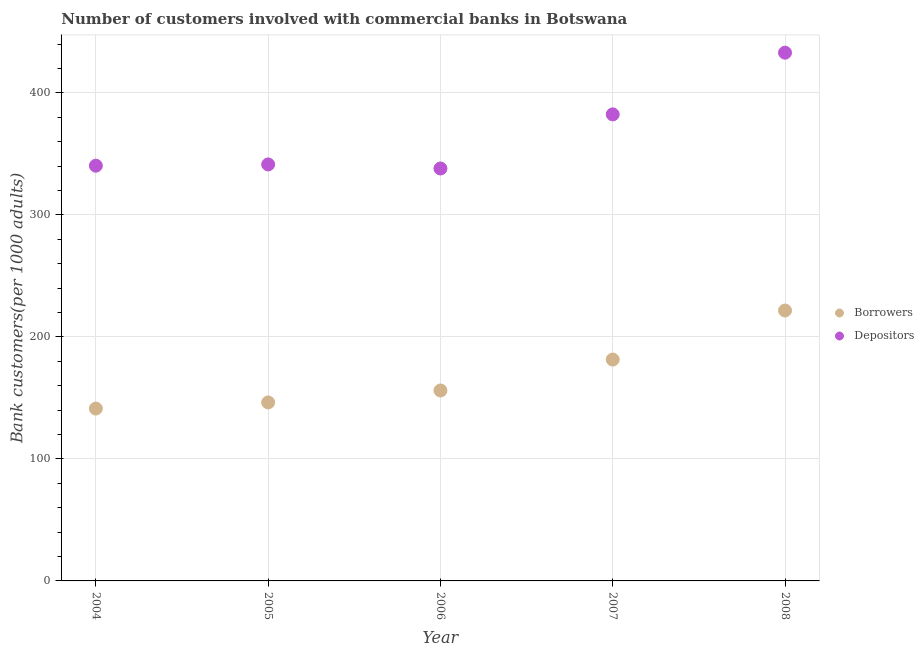How many different coloured dotlines are there?
Your answer should be compact. 2. Is the number of dotlines equal to the number of legend labels?
Offer a terse response. Yes. What is the number of borrowers in 2006?
Provide a short and direct response. 156.11. Across all years, what is the maximum number of depositors?
Your answer should be compact. 433.02. Across all years, what is the minimum number of borrowers?
Offer a terse response. 141.29. In which year was the number of depositors maximum?
Provide a succinct answer. 2008. What is the total number of depositors in the graph?
Your answer should be compact. 1835.3. What is the difference between the number of borrowers in 2004 and that in 2005?
Provide a short and direct response. -5.03. What is the difference between the number of borrowers in 2006 and the number of depositors in 2004?
Your answer should be very brief. -184.26. What is the average number of depositors per year?
Make the answer very short. 367.06. In the year 2006, what is the difference between the number of depositors and number of borrowers?
Your answer should be compact. 181.96. In how many years, is the number of depositors greater than 420?
Provide a short and direct response. 1. What is the ratio of the number of borrowers in 2004 to that in 2008?
Provide a succinct answer. 0.64. Is the number of borrowers in 2005 less than that in 2006?
Your answer should be very brief. Yes. Is the difference between the number of borrowers in 2004 and 2005 greater than the difference between the number of depositors in 2004 and 2005?
Offer a very short reply. No. What is the difference between the highest and the second highest number of borrowers?
Your response must be concise. 40.2. What is the difference between the highest and the lowest number of depositors?
Keep it short and to the point. 94.94. Is the sum of the number of borrowers in 2005 and 2007 greater than the maximum number of depositors across all years?
Ensure brevity in your answer.  No. Is the number of depositors strictly greater than the number of borrowers over the years?
Provide a short and direct response. Yes. How many dotlines are there?
Your answer should be very brief. 2. How many years are there in the graph?
Keep it short and to the point. 5. What is the difference between two consecutive major ticks on the Y-axis?
Your answer should be compact. 100. What is the title of the graph?
Offer a terse response. Number of customers involved with commercial banks in Botswana. What is the label or title of the X-axis?
Offer a very short reply. Year. What is the label or title of the Y-axis?
Your answer should be compact. Bank customers(per 1000 adults). What is the Bank customers(per 1000 adults) in Borrowers in 2004?
Offer a terse response. 141.29. What is the Bank customers(per 1000 adults) of Depositors in 2004?
Ensure brevity in your answer.  340.37. What is the Bank customers(per 1000 adults) of Borrowers in 2005?
Your answer should be very brief. 146.32. What is the Bank customers(per 1000 adults) of Depositors in 2005?
Keep it short and to the point. 341.4. What is the Bank customers(per 1000 adults) in Borrowers in 2006?
Offer a terse response. 156.11. What is the Bank customers(per 1000 adults) in Depositors in 2006?
Offer a terse response. 338.08. What is the Bank customers(per 1000 adults) of Borrowers in 2007?
Offer a terse response. 181.45. What is the Bank customers(per 1000 adults) of Depositors in 2007?
Offer a terse response. 382.43. What is the Bank customers(per 1000 adults) in Borrowers in 2008?
Your response must be concise. 221.65. What is the Bank customers(per 1000 adults) in Depositors in 2008?
Keep it short and to the point. 433.02. Across all years, what is the maximum Bank customers(per 1000 adults) of Borrowers?
Offer a very short reply. 221.65. Across all years, what is the maximum Bank customers(per 1000 adults) of Depositors?
Your response must be concise. 433.02. Across all years, what is the minimum Bank customers(per 1000 adults) of Borrowers?
Your response must be concise. 141.29. Across all years, what is the minimum Bank customers(per 1000 adults) in Depositors?
Offer a terse response. 338.08. What is the total Bank customers(per 1000 adults) of Borrowers in the graph?
Provide a short and direct response. 846.82. What is the total Bank customers(per 1000 adults) in Depositors in the graph?
Ensure brevity in your answer.  1835.3. What is the difference between the Bank customers(per 1000 adults) in Borrowers in 2004 and that in 2005?
Your answer should be compact. -5.03. What is the difference between the Bank customers(per 1000 adults) of Depositors in 2004 and that in 2005?
Offer a very short reply. -1.03. What is the difference between the Bank customers(per 1000 adults) of Borrowers in 2004 and that in 2006?
Your answer should be very brief. -14.83. What is the difference between the Bank customers(per 1000 adults) of Depositors in 2004 and that in 2006?
Your response must be concise. 2.3. What is the difference between the Bank customers(per 1000 adults) of Borrowers in 2004 and that in 2007?
Ensure brevity in your answer.  -40.17. What is the difference between the Bank customers(per 1000 adults) of Depositors in 2004 and that in 2007?
Ensure brevity in your answer.  -42.06. What is the difference between the Bank customers(per 1000 adults) in Borrowers in 2004 and that in 2008?
Make the answer very short. -80.36. What is the difference between the Bank customers(per 1000 adults) in Depositors in 2004 and that in 2008?
Your answer should be very brief. -92.65. What is the difference between the Bank customers(per 1000 adults) in Borrowers in 2005 and that in 2006?
Your answer should be compact. -9.79. What is the difference between the Bank customers(per 1000 adults) of Depositors in 2005 and that in 2006?
Offer a terse response. 3.33. What is the difference between the Bank customers(per 1000 adults) in Borrowers in 2005 and that in 2007?
Your response must be concise. -35.13. What is the difference between the Bank customers(per 1000 adults) of Depositors in 2005 and that in 2007?
Offer a very short reply. -41.03. What is the difference between the Bank customers(per 1000 adults) in Borrowers in 2005 and that in 2008?
Make the answer very short. -75.33. What is the difference between the Bank customers(per 1000 adults) of Depositors in 2005 and that in 2008?
Offer a terse response. -91.62. What is the difference between the Bank customers(per 1000 adults) of Borrowers in 2006 and that in 2007?
Your response must be concise. -25.34. What is the difference between the Bank customers(per 1000 adults) in Depositors in 2006 and that in 2007?
Offer a very short reply. -44.36. What is the difference between the Bank customers(per 1000 adults) of Borrowers in 2006 and that in 2008?
Give a very brief answer. -65.54. What is the difference between the Bank customers(per 1000 adults) of Depositors in 2006 and that in 2008?
Provide a succinct answer. -94.94. What is the difference between the Bank customers(per 1000 adults) in Borrowers in 2007 and that in 2008?
Provide a short and direct response. -40.2. What is the difference between the Bank customers(per 1000 adults) in Depositors in 2007 and that in 2008?
Provide a succinct answer. -50.58. What is the difference between the Bank customers(per 1000 adults) in Borrowers in 2004 and the Bank customers(per 1000 adults) in Depositors in 2005?
Give a very brief answer. -200.12. What is the difference between the Bank customers(per 1000 adults) of Borrowers in 2004 and the Bank customers(per 1000 adults) of Depositors in 2006?
Provide a succinct answer. -196.79. What is the difference between the Bank customers(per 1000 adults) of Borrowers in 2004 and the Bank customers(per 1000 adults) of Depositors in 2007?
Your response must be concise. -241.15. What is the difference between the Bank customers(per 1000 adults) of Borrowers in 2004 and the Bank customers(per 1000 adults) of Depositors in 2008?
Your answer should be compact. -291.73. What is the difference between the Bank customers(per 1000 adults) in Borrowers in 2005 and the Bank customers(per 1000 adults) in Depositors in 2006?
Provide a short and direct response. -191.76. What is the difference between the Bank customers(per 1000 adults) of Borrowers in 2005 and the Bank customers(per 1000 adults) of Depositors in 2007?
Your answer should be very brief. -236.12. What is the difference between the Bank customers(per 1000 adults) of Borrowers in 2005 and the Bank customers(per 1000 adults) of Depositors in 2008?
Offer a very short reply. -286.7. What is the difference between the Bank customers(per 1000 adults) in Borrowers in 2006 and the Bank customers(per 1000 adults) in Depositors in 2007?
Give a very brief answer. -226.32. What is the difference between the Bank customers(per 1000 adults) of Borrowers in 2006 and the Bank customers(per 1000 adults) of Depositors in 2008?
Your answer should be very brief. -276.9. What is the difference between the Bank customers(per 1000 adults) in Borrowers in 2007 and the Bank customers(per 1000 adults) in Depositors in 2008?
Your answer should be very brief. -251.56. What is the average Bank customers(per 1000 adults) in Borrowers per year?
Your answer should be very brief. 169.36. What is the average Bank customers(per 1000 adults) of Depositors per year?
Your answer should be compact. 367.06. In the year 2004, what is the difference between the Bank customers(per 1000 adults) in Borrowers and Bank customers(per 1000 adults) in Depositors?
Provide a short and direct response. -199.09. In the year 2005, what is the difference between the Bank customers(per 1000 adults) of Borrowers and Bank customers(per 1000 adults) of Depositors?
Your answer should be compact. -195.08. In the year 2006, what is the difference between the Bank customers(per 1000 adults) of Borrowers and Bank customers(per 1000 adults) of Depositors?
Provide a succinct answer. -181.96. In the year 2007, what is the difference between the Bank customers(per 1000 adults) of Borrowers and Bank customers(per 1000 adults) of Depositors?
Offer a very short reply. -200.98. In the year 2008, what is the difference between the Bank customers(per 1000 adults) of Borrowers and Bank customers(per 1000 adults) of Depositors?
Your answer should be compact. -211.37. What is the ratio of the Bank customers(per 1000 adults) in Borrowers in 2004 to that in 2005?
Keep it short and to the point. 0.97. What is the ratio of the Bank customers(per 1000 adults) of Borrowers in 2004 to that in 2006?
Your response must be concise. 0.91. What is the ratio of the Bank customers(per 1000 adults) in Depositors in 2004 to that in 2006?
Keep it short and to the point. 1.01. What is the ratio of the Bank customers(per 1000 adults) in Borrowers in 2004 to that in 2007?
Provide a short and direct response. 0.78. What is the ratio of the Bank customers(per 1000 adults) of Depositors in 2004 to that in 2007?
Give a very brief answer. 0.89. What is the ratio of the Bank customers(per 1000 adults) in Borrowers in 2004 to that in 2008?
Your answer should be compact. 0.64. What is the ratio of the Bank customers(per 1000 adults) in Depositors in 2004 to that in 2008?
Your response must be concise. 0.79. What is the ratio of the Bank customers(per 1000 adults) of Borrowers in 2005 to that in 2006?
Keep it short and to the point. 0.94. What is the ratio of the Bank customers(per 1000 adults) in Depositors in 2005 to that in 2006?
Offer a terse response. 1.01. What is the ratio of the Bank customers(per 1000 adults) of Borrowers in 2005 to that in 2007?
Make the answer very short. 0.81. What is the ratio of the Bank customers(per 1000 adults) in Depositors in 2005 to that in 2007?
Your answer should be very brief. 0.89. What is the ratio of the Bank customers(per 1000 adults) of Borrowers in 2005 to that in 2008?
Ensure brevity in your answer.  0.66. What is the ratio of the Bank customers(per 1000 adults) of Depositors in 2005 to that in 2008?
Offer a very short reply. 0.79. What is the ratio of the Bank customers(per 1000 adults) of Borrowers in 2006 to that in 2007?
Offer a very short reply. 0.86. What is the ratio of the Bank customers(per 1000 adults) in Depositors in 2006 to that in 2007?
Your answer should be compact. 0.88. What is the ratio of the Bank customers(per 1000 adults) of Borrowers in 2006 to that in 2008?
Your answer should be very brief. 0.7. What is the ratio of the Bank customers(per 1000 adults) in Depositors in 2006 to that in 2008?
Make the answer very short. 0.78. What is the ratio of the Bank customers(per 1000 adults) in Borrowers in 2007 to that in 2008?
Give a very brief answer. 0.82. What is the ratio of the Bank customers(per 1000 adults) in Depositors in 2007 to that in 2008?
Give a very brief answer. 0.88. What is the difference between the highest and the second highest Bank customers(per 1000 adults) of Borrowers?
Keep it short and to the point. 40.2. What is the difference between the highest and the second highest Bank customers(per 1000 adults) of Depositors?
Your response must be concise. 50.58. What is the difference between the highest and the lowest Bank customers(per 1000 adults) of Borrowers?
Offer a very short reply. 80.36. What is the difference between the highest and the lowest Bank customers(per 1000 adults) of Depositors?
Your response must be concise. 94.94. 